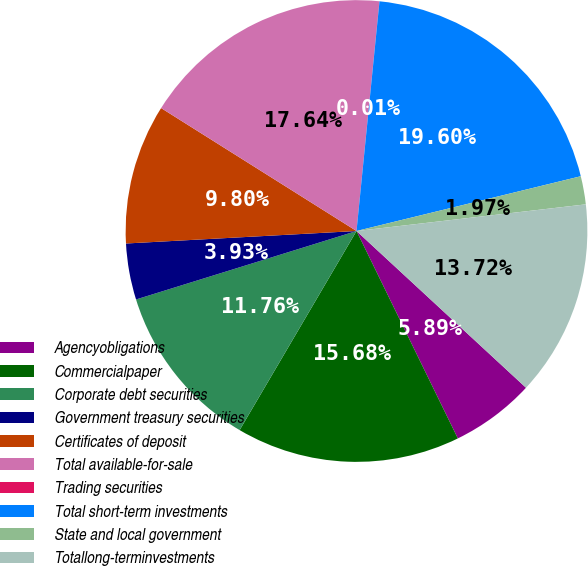<chart> <loc_0><loc_0><loc_500><loc_500><pie_chart><fcel>Agencyobligations<fcel>Commercialpaper<fcel>Corporate debt securities<fcel>Government treasury securities<fcel>Certificates of deposit<fcel>Total available-for-sale<fcel>Trading securities<fcel>Total short-term investments<fcel>State and local government<fcel>Totallong-terminvestments<nl><fcel>5.89%<fcel>15.68%<fcel>11.76%<fcel>3.93%<fcel>9.8%<fcel>17.64%<fcel>0.01%<fcel>19.6%<fcel>1.97%<fcel>13.72%<nl></chart> 